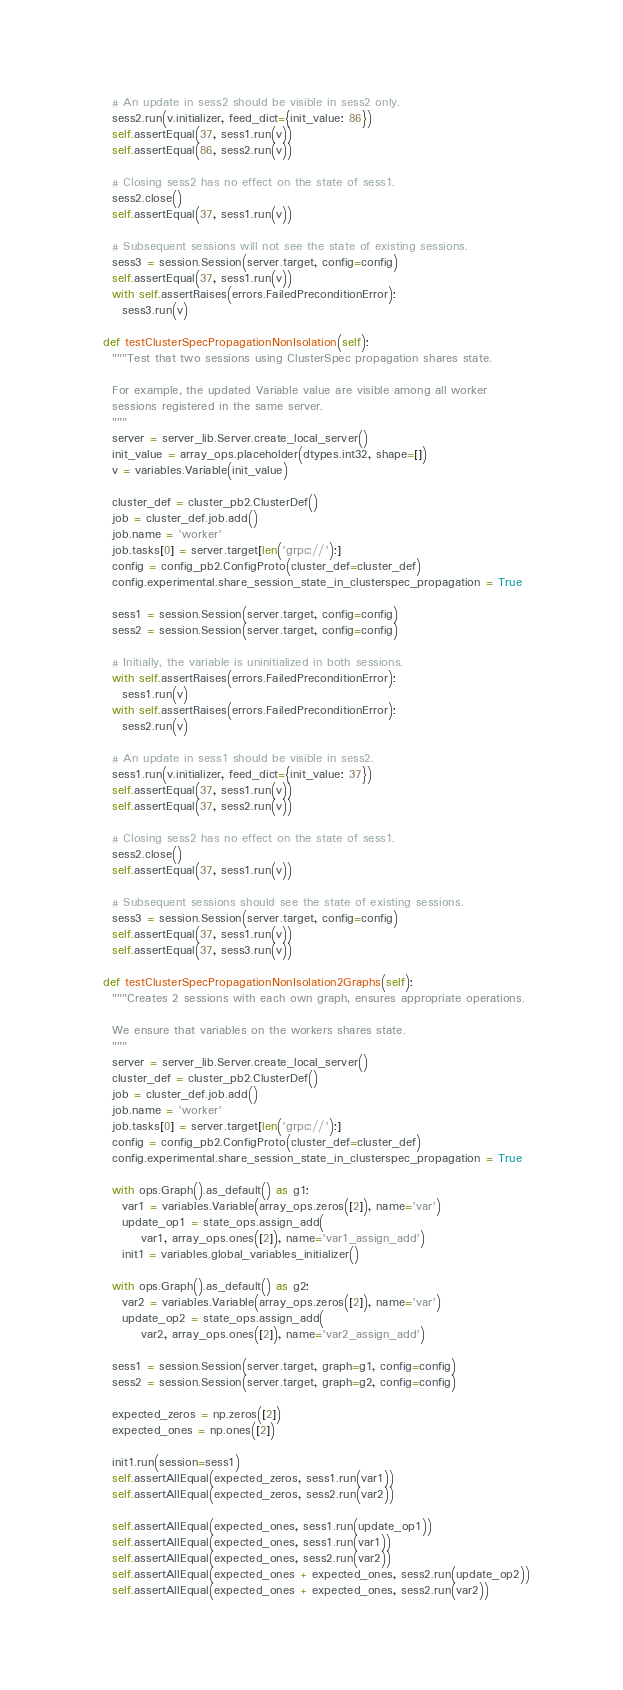Convert code to text. <code><loc_0><loc_0><loc_500><loc_500><_Python_>
    # An update in sess2 should be visible in sess2 only.
    sess2.run(v.initializer, feed_dict={init_value: 86})
    self.assertEqual(37, sess1.run(v))
    self.assertEqual(86, sess2.run(v))

    # Closing sess2 has no effect on the state of sess1.
    sess2.close()
    self.assertEqual(37, sess1.run(v))

    # Subsequent sessions will not see the state of existing sessions.
    sess3 = session.Session(server.target, config=config)
    self.assertEqual(37, sess1.run(v))
    with self.assertRaises(errors.FailedPreconditionError):
      sess3.run(v)

  def testClusterSpecPropagationNonIsolation(self):
    """Test that two sessions using ClusterSpec propagation shares state.

    For example, the updated Variable value are visible among all worker
    sessions registered in the same server.
    """
    server = server_lib.Server.create_local_server()
    init_value = array_ops.placeholder(dtypes.int32, shape=[])
    v = variables.Variable(init_value)

    cluster_def = cluster_pb2.ClusterDef()
    job = cluster_def.job.add()
    job.name = 'worker'
    job.tasks[0] = server.target[len('grpc://'):]
    config = config_pb2.ConfigProto(cluster_def=cluster_def)
    config.experimental.share_session_state_in_clusterspec_propagation = True

    sess1 = session.Session(server.target, config=config)
    sess2 = session.Session(server.target, config=config)

    # Initially, the variable is uninitialized in both sessions.
    with self.assertRaises(errors.FailedPreconditionError):
      sess1.run(v)
    with self.assertRaises(errors.FailedPreconditionError):
      sess2.run(v)

    # An update in sess1 should be visible in sess2.
    sess1.run(v.initializer, feed_dict={init_value: 37})
    self.assertEqual(37, sess1.run(v))
    self.assertEqual(37, sess2.run(v))

    # Closing sess2 has no effect on the state of sess1.
    sess2.close()
    self.assertEqual(37, sess1.run(v))

    # Subsequent sessions should see the state of existing sessions.
    sess3 = session.Session(server.target, config=config)
    self.assertEqual(37, sess1.run(v))
    self.assertEqual(37, sess3.run(v))

  def testClusterSpecPropagationNonIsolation2Graphs(self):
    """Creates 2 sessions with each own graph, ensures appropriate operations.

    We ensure that variables on the workers shares state.
    """
    server = server_lib.Server.create_local_server()
    cluster_def = cluster_pb2.ClusterDef()
    job = cluster_def.job.add()
    job.name = 'worker'
    job.tasks[0] = server.target[len('grpc://'):]
    config = config_pb2.ConfigProto(cluster_def=cluster_def)
    config.experimental.share_session_state_in_clusterspec_propagation = True

    with ops.Graph().as_default() as g1:
      var1 = variables.Variable(array_ops.zeros([2]), name='var')
      update_op1 = state_ops.assign_add(
          var1, array_ops.ones([2]), name='var1_assign_add')
      init1 = variables.global_variables_initializer()

    with ops.Graph().as_default() as g2:
      var2 = variables.Variable(array_ops.zeros([2]), name='var')
      update_op2 = state_ops.assign_add(
          var2, array_ops.ones([2]), name='var2_assign_add')

    sess1 = session.Session(server.target, graph=g1, config=config)
    sess2 = session.Session(server.target, graph=g2, config=config)

    expected_zeros = np.zeros([2])
    expected_ones = np.ones([2])

    init1.run(session=sess1)
    self.assertAllEqual(expected_zeros, sess1.run(var1))
    self.assertAllEqual(expected_zeros, sess2.run(var2))

    self.assertAllEqual(expected_ones, sess1.run(update_op1))
    self.assertAllEqual(expected_ones, sess1.run(var1))
    self.assertAllEqual(expected_ones, sess2.run(var2))
    self.assertAllEqual(expected_ones + expected_ones, sess2.run(update_op2))
    self.assertAllEqual(expected_ones + expected_ones, sess2.run(var2))</code> 